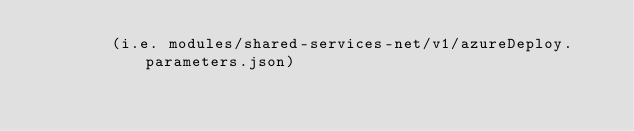<code> <loc_0><loc_0><loc_500><loc_500><_Python_>        (i.e. modules/shared-services-net/v1/azureDeploy.parameters.json)</code> 